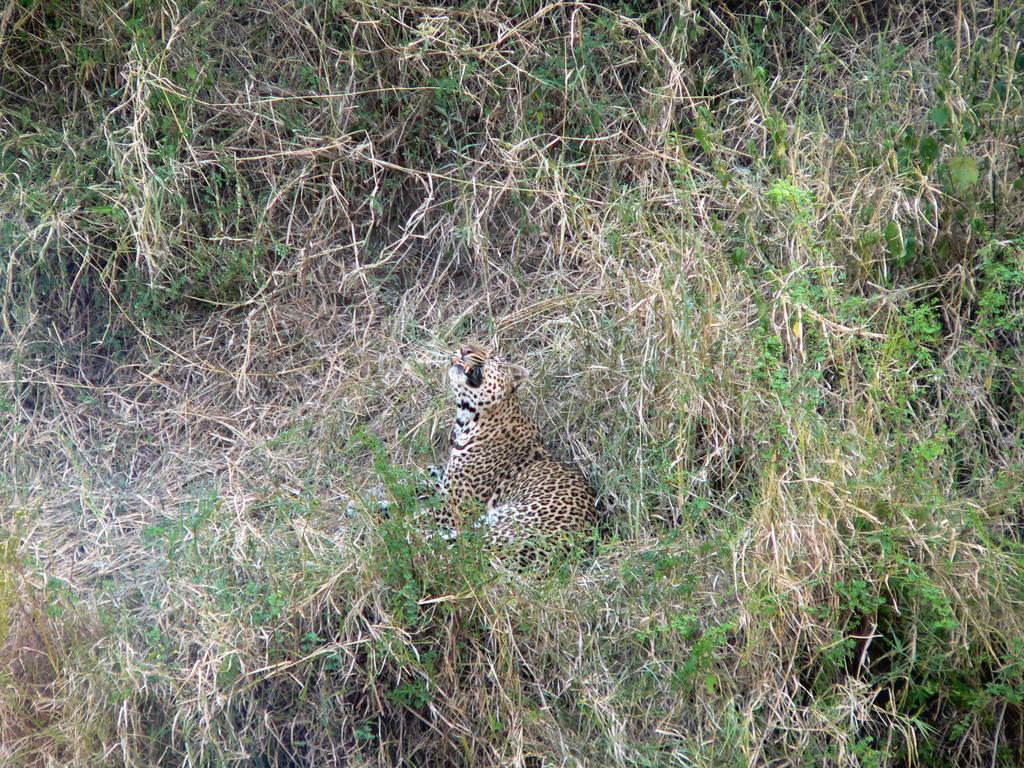Please provide a concise description of this image. In the middle I can see a leopard on the grass. This image is taken may be on the ground during a day. 